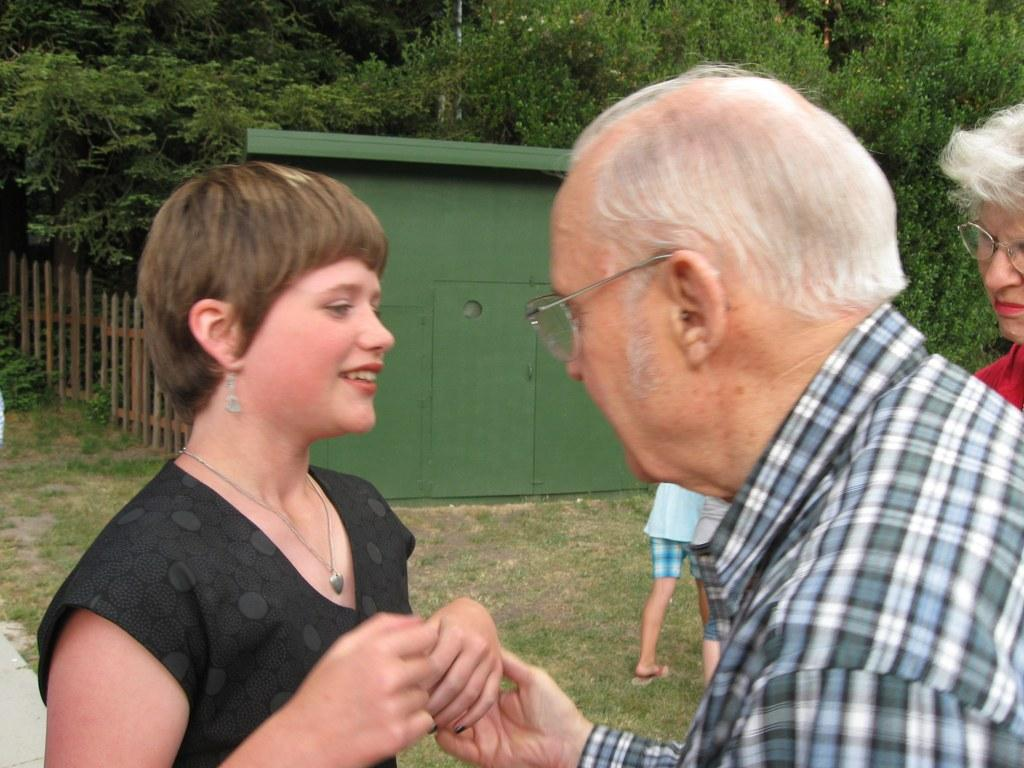How many people are in the image? There are people in the image, but the exact number is not specified. What can be observed about some of the people in the image? Some people in the image are wearing glasses. What can be seen in the background of the image? There are trees, a shed, and a fence in the background of the image. What type of wine is being served at the picnic in the image? There is no picnic or wine present in the image; it features people, trees, a shed, and a fence in the background. How many bricks are visible in the image? There is no mention of bricks in the image, so it is not possible to determine their number. 